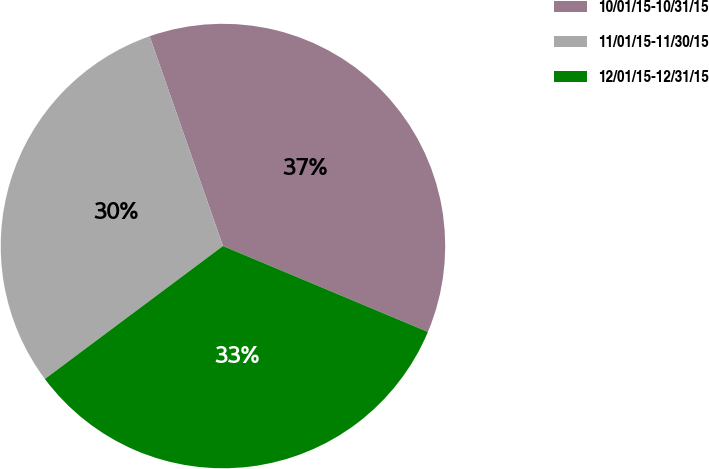Convert chart to OTSL. <chart><loc_0><loc_0><loc_500><loc_500><pie_chart><fcel>10/01/15-10/31/15<fcel>11/01/15-11/30/15<fcel>12/01/15-12/31/15<nl><fcel>36.67%<fcel>29.86%<fcel>33.48%<nl></chart> 